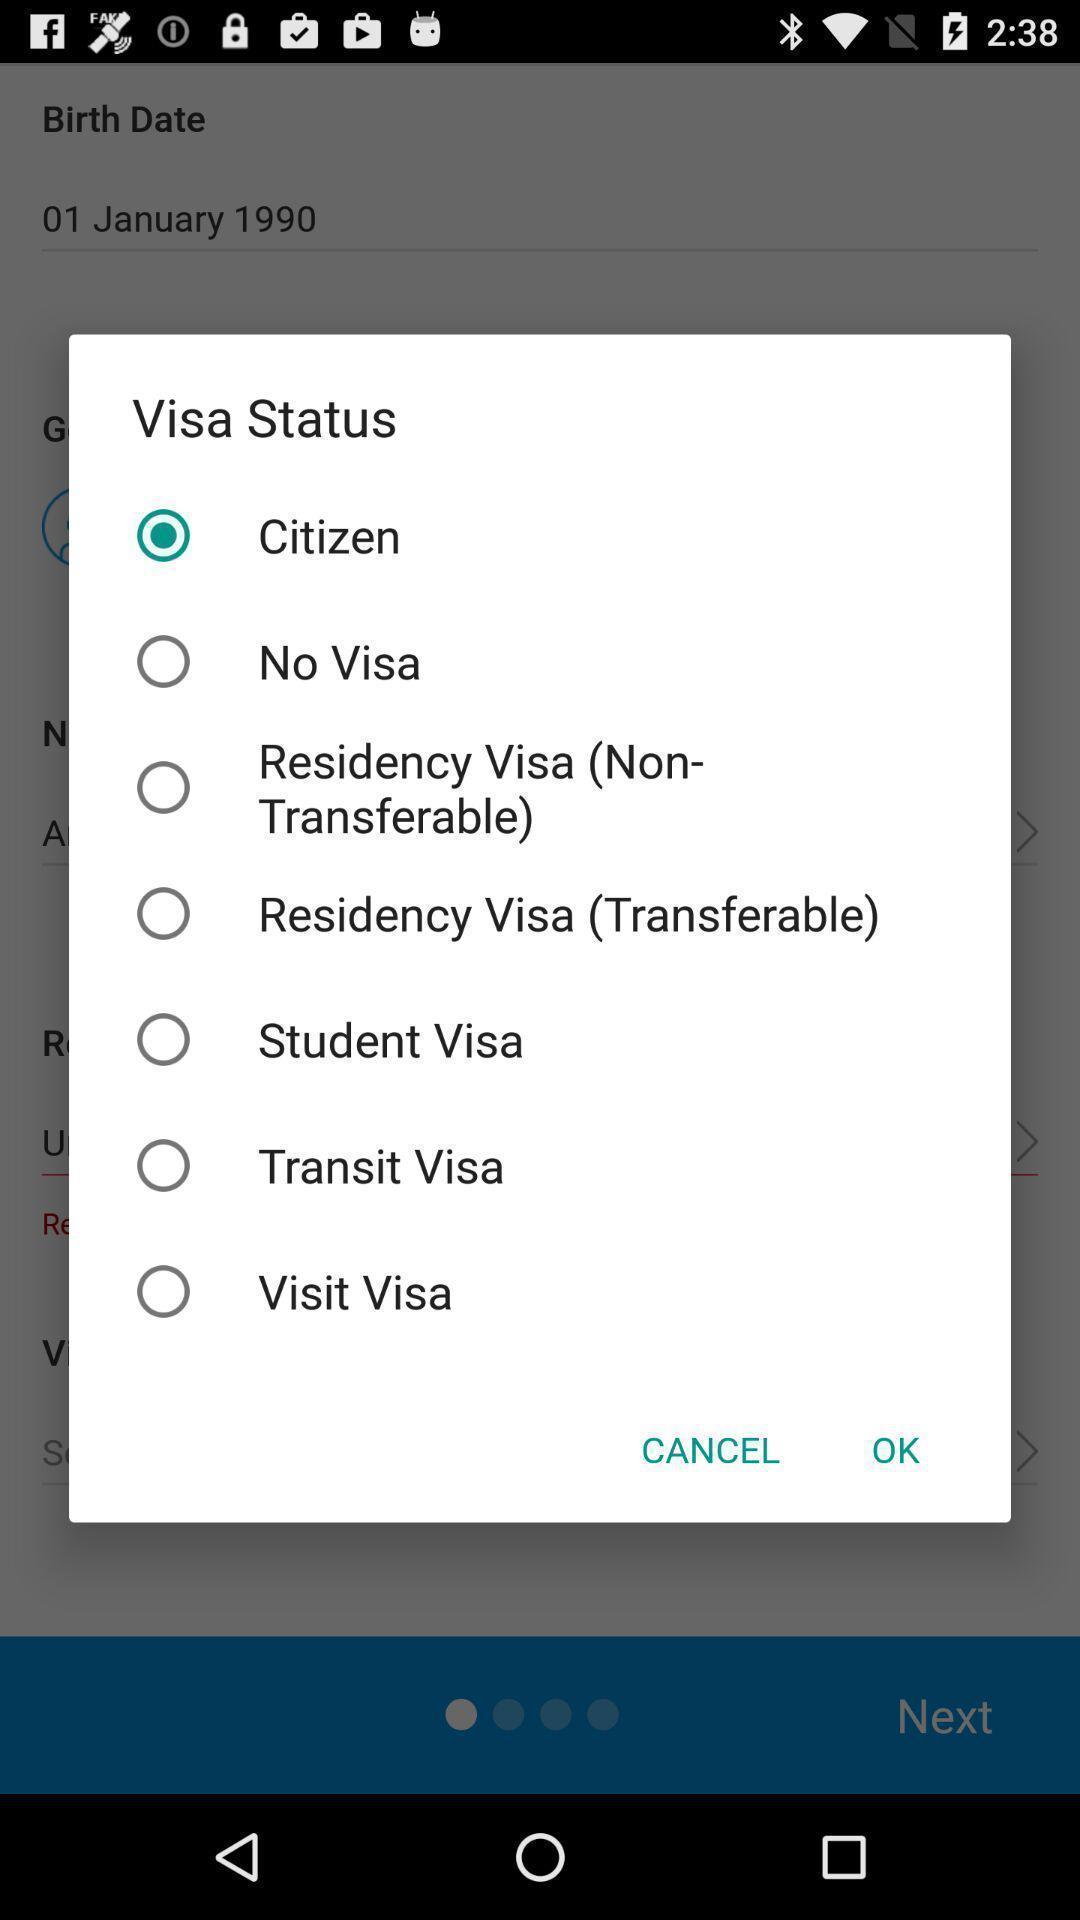Summarize the main components in this picture. Popup page for choosing a visa status for an app. 